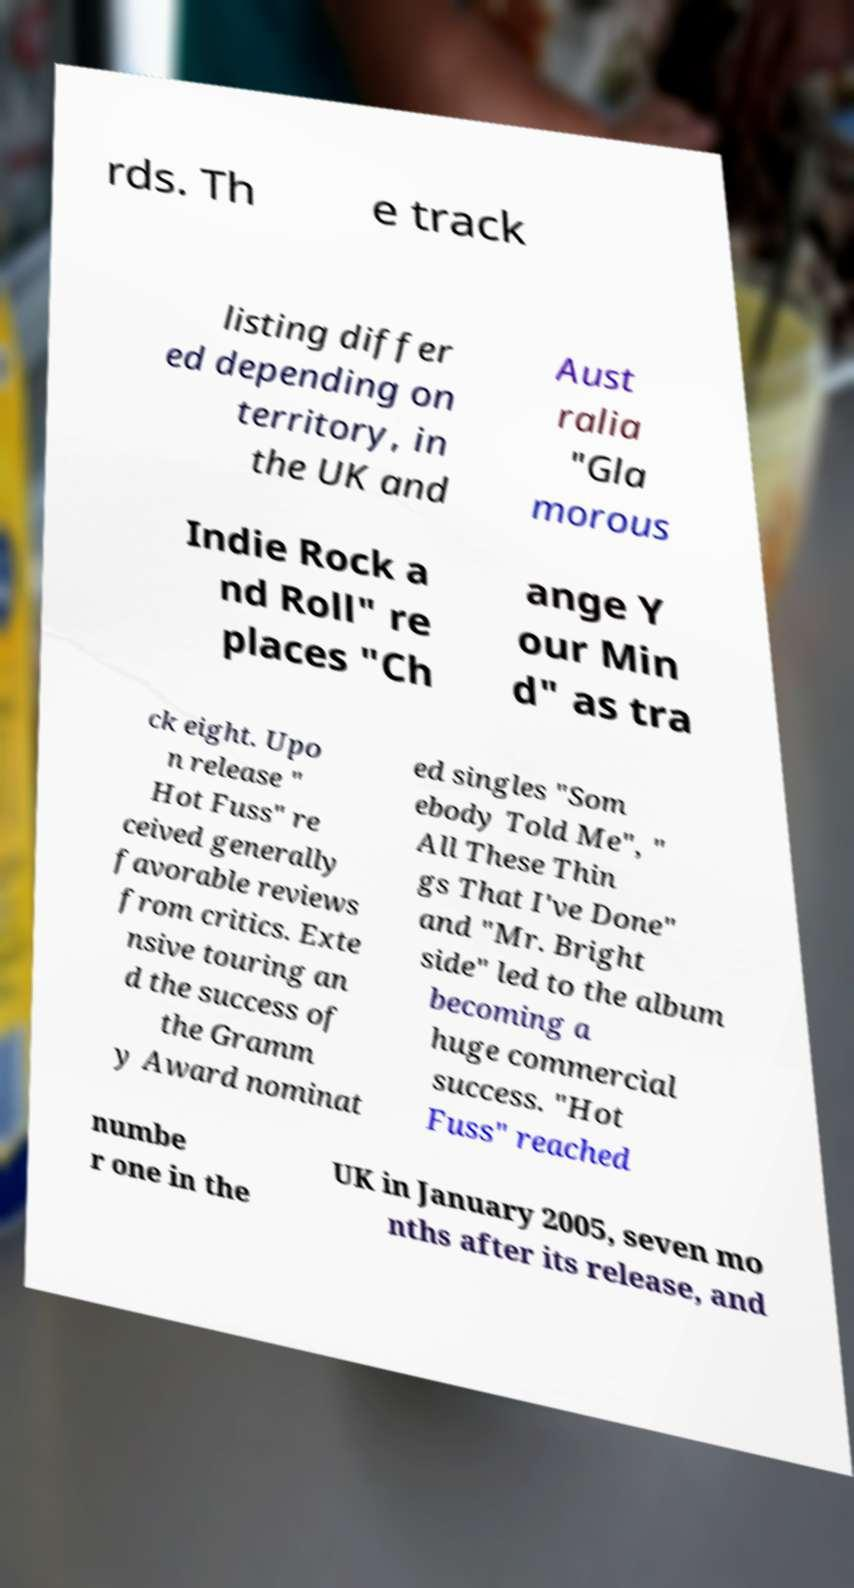Please read and relay the text visible in this image. What does it say? rds. Th e track listing differ ed depending on territory, in the UK and Aust ralia "Gla morous Indie Rock a nd Roll" re places "Ch ange Y our Min d" as tra ck eight. Upo n release " Hot Fuss" re ceived generally favorable reviews from critics. Exte nsive touring an d the success of the Gramm y Award nominat ed singles "Som ebody Told Me", " All These Thin gs That I've Done" and "Mr. Bright side" led to the album becoming a huge commercial success. "Hot Fuss" reached numbe r one in the UK in January 2005, seven mo nths after its release, and 